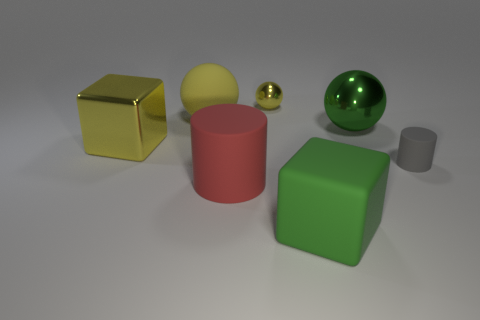Add 1 large cubes. How many objects exist? 8 Subtract all small metallic balls. How many balls are left? 2 Subtract all green balls. How many balls are left? 2 Subtract all blocks. How many objects are left? 5 Subtract 2 cylinders. How many cylinders are left? 0 Subtract all green blocks. Subtract all cyan balls. How many blocks are left? 1 Subtract all yellow cylinders. How many blue blocks are left? 0 Subtract all yellow objects. Subtract all rubber objects. How many objects are left? 0 Add 4 metallic things. How many metallic things are left? 7 Add 2 big red balls. How many big red balls exist? 2 